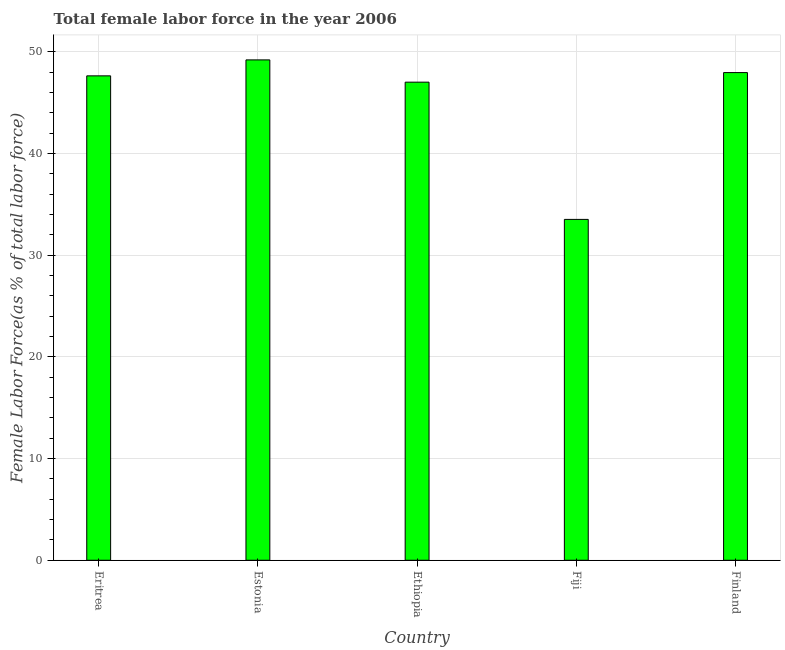Does the graph contain any zero values?
Offer a terse response. No. What is the title of the graph?
Your response must be concise. Total female labor force in the year 2006. What is the label or title of the X-axis?
Ensure brevity in your answer.  Country. What is the label or title of the Y-axis?
Give a very brief answer. Female Labor Force(as % of total labor force). What is the total female labor force in Eritrea?
Your answer should be compact. 47.63. Across all countries, what is the maximum total female labor force?
Offer a very short reply. 49.2. Across all countries, what is the minimum total female labor force?
Offer a very short reply. 33.52. In which country was the total female labor force maximum?
Provide a short and direct response. Estonia. In which country was the total female labor force minimum?
Your answer should be compact. Fiji. What is the sum of the total female labor force?
Provide a succinct answer. 225.33. What is the difference between the total female labor force in Estonia and Fiji?
Your answer should be compact. 15.69. What is the average total female labor force per country?
Offer a terse response. 45.06. What is the median total female labor force?
Your answer should be compact. 47.63. What is the ratio of the total female labor force in Estonia to that in Finland?
Keep it short and to the point. 1.03. Is the total female labor force in Eritrea less than that in Fiji?
Offer a terse response. No. Is the difference between the total female labor force in Eritrea and Ethiopia greater than the difference between any two countries?
Keep it short and to the point. No. What is the difference between the highest and the second highest total female labor force?
Your answer should be compact. 1.25. What is the difference between the highest and the lowest total female labor force?
Your answer should be very brief. 15.69. In how many countries, is the total female labor force greater than the average total female labor force taken over all countries?
Make the answer very short. 4. Are all the bars in the graph horizontal?
Make the answer very short. No. How many countries are there in the graph?
Keep it short and to the point. 5. Are the values on the major ticks of Y-axis written in scientific E-notation?
Keep it short and to the point. No. What is the Female Labor Force(as % of total labor force) in Eritrea?
Keep it short and to the point. 47.63. What is the Female Labor Force(as % of total labor force) of Estonia?
Give a very brief answer. 49.2. What is the Female Labor Force(as % of total labor force) in Ethiopia?
Keep it short and to the point. 47.01. What is the Female Labor Force(as % of total labor force) in Fiji?
Keep it short and to the point. 33.52. What is the Female Labor Force(as % of total labor force) of Finland?
Offer a very short reply. 47.96. What is the difference between the Female Labor Force(as % of total labor force) in Eritrea and Estonia?
Ensure brevity in your answer.  -1.57. What is the difference between the Female Labor Force(as % of total labor force) in Eritrea and Ethiopia?
Offer a very short reply. 0.62. What is the difference between the Female Labor Force(as % of total labor force) in Eritrea and Fiji?
Provide a short and direct response. 14.12. What is the difference between the Female Labor Force(as % of total labor force) in Eritrea and Finland?
Your answer should be compact. -0.32. What is the difference between the Female Labor Force(as % of total labor force) in Estonia and Ethiopia?
Offer a terse response. 2.19. What is the difference between the Female Labor Force(as % of total labor force) in Estonia and Fiji?
Make the answer very short. 15.69. What is the difference between the Female Labor Force(as % of total labor force) in Estonia and Finland?
Offer a terse response. 1.25. What is the difference between the Female Labor Force(as % of total labor force) in Ethiopia and Fiji?
Your answer should be compact. 13.49. What is the difference between the Female Labor Force(as % of total labor force) in Ethiopia and Finland?
Offer a very short reply. -0.94. What is the difference between the Female Labor Force(as % of total labor force) in Fiji and Finland?
Your answer should be very brief. -14.44. What is the ratio of the Female Labor Force(as % of total labor force) in Eritrea to that in Ethiopia?
Your answer should be very brief. 1.01. What is the ratio of the Female Labor Force(as % of total labor force) in Eritrea to that in Fiji?
Provide a succinct answer. 1.42. What is the ratio of the Female Labor Force(as % of total labor force) in Estonia to that in Ethiopia?
Your response must be concise. 1.05. What is the ratio of the Female Labor Force(as % of total labor force) in Estonia to that in Fiji?
Keep it short and to the point. 1.47. What is the ratio of the Female Labor Force(as % of total labor force) in Ethiopia to that in Fiji?
Ensure brevity in your answer.  1.4. What is the ratio of the Female Labor Force(as % of total labor force) in Ethiopia to that in Finland?
Make the answer very short. 0.98. What is the ratio of the Female Labor Force(as % of total labor force) in Fiji to that in Finland?
Make the answer very short. 0.7. 